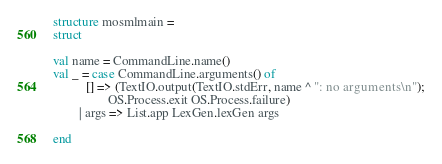Convert code to text. <code><loc_0><loc_0><loc_500><loc_500><_SML_>structure mosmlmain =
struct

val name = CommandLine.name()
val _ = case CommandLine.arguments() of
          [] => (TextIO.output(TextIO.stdErr, name ^ ": no arguments\n");
                 OS.Process.exit OS.Process.failure)
        | args => List.app LexGen.lexGen args

end
</code> 